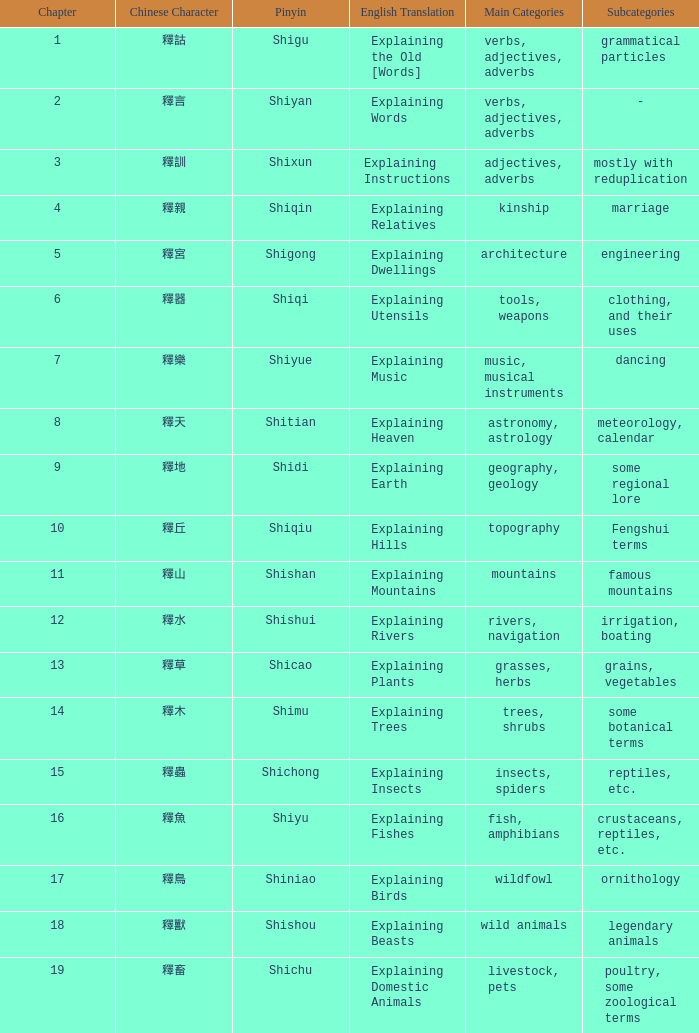Name the chinese with subject of adjectives, adverbs, mostly with reduplication 釋訓. 